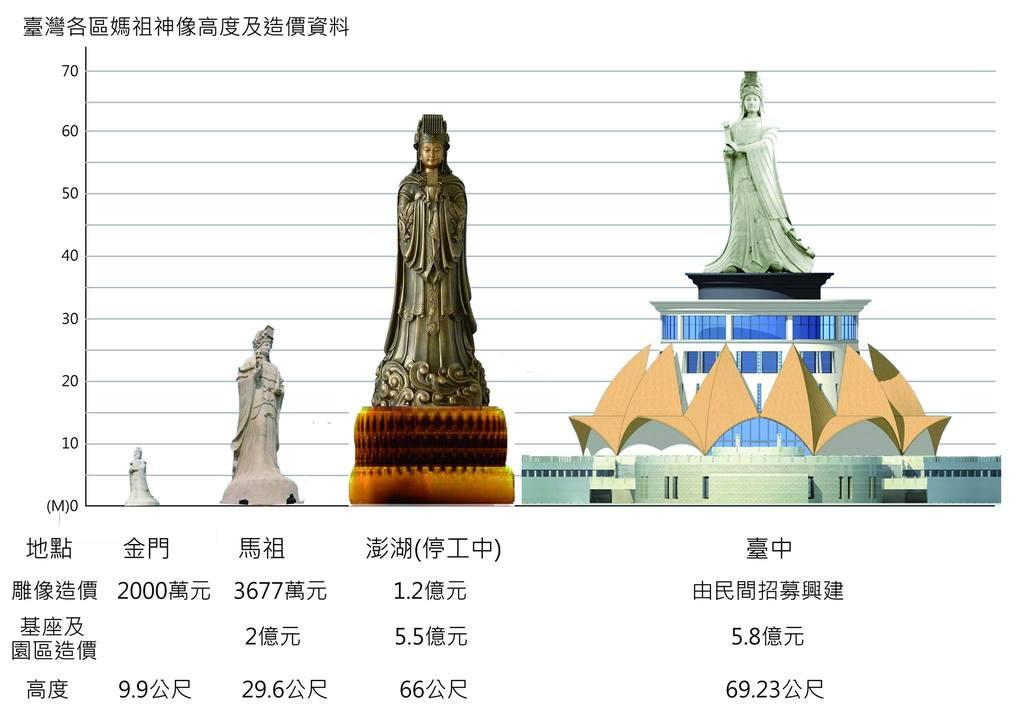What is the main subject of the paper in the image? The paper contains images of statues. Can you describe the setting of one of the statues depicted on the paper? One statue is depicted on a building. Is there any text associated with the statues on the paper? Yes, there is writing on the statue. What type of muscle can be seen flexing in the image? There is no muscle present in the image; it features images of statues on a paper. What is the reason for the statue's existence in the image? The image does not provide information about the reason for the statue's existence, as it only shows images of statues on a paper. 